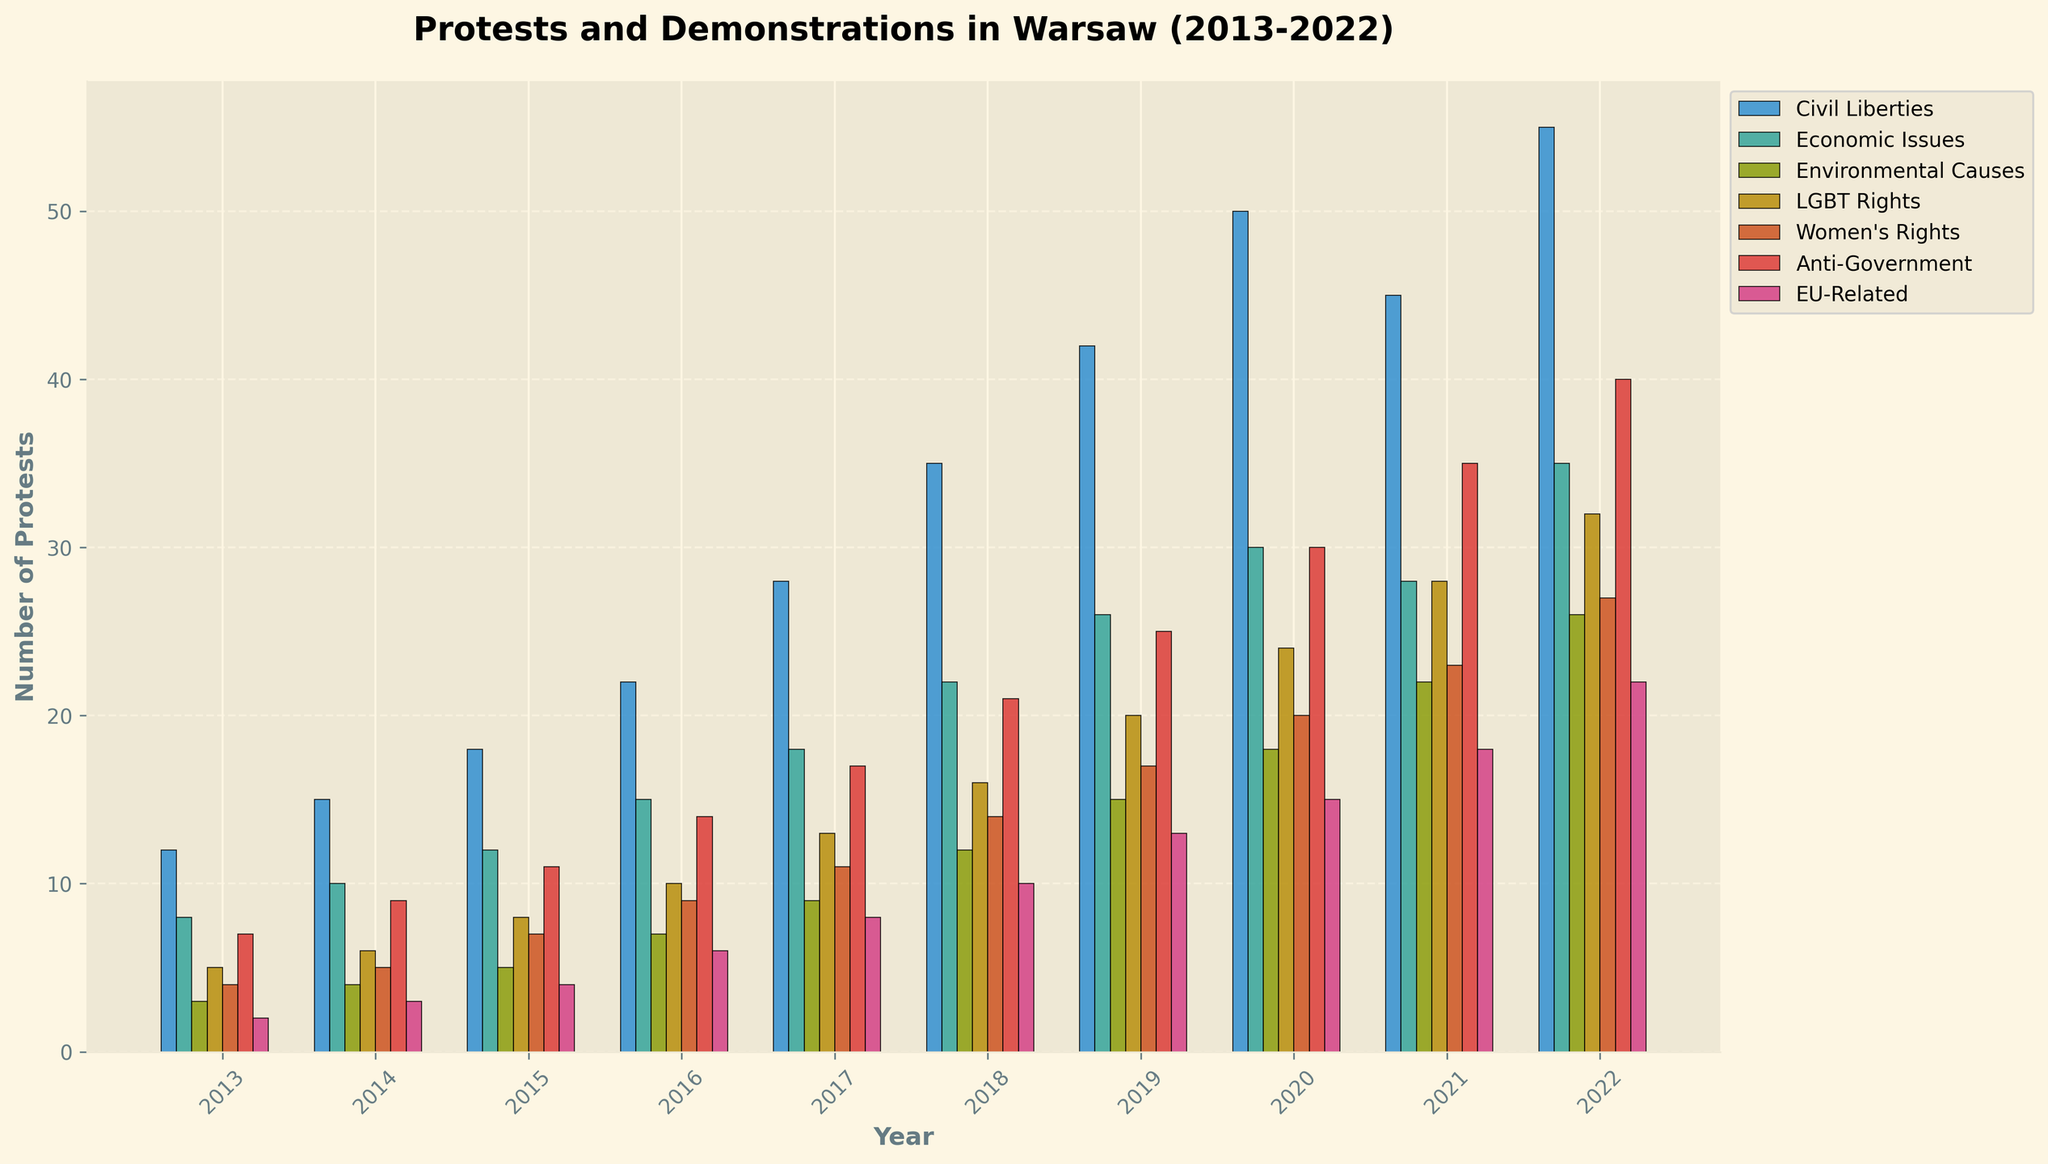What's the total number of protests for Civil Liberties over the decade? Sum the values for Civil Liberties from 2013 to 2022 (12 + 15 + 18 + 22 + 28 + 35 + 42 + 50 + 45 + 55). The operation is 12 + 15 + 18 + 22 + 28 + 35 + 42 + 50 + 45 + 55 = 322.
Answer: 322 In which year did Economic Issues protests peak? Identify the highest bar in the Economic Issues category across all years. The peak is in 2022 with 35 protests.
Answer: 2022 How did the number of Environmental Causes protests change from 2015 to 2021? Calculate the difference between the number of protests in 2015 and 2021 for Environmental Causes. The operation is 22 - 5 = 17.
Answer: Increased by 17 Between 2017 and 2019, which cause had the fastest growth in protests? Compare the growth numbers for all categories between 2017 and 2019. Civil Liberties grew from 28 to 42 (14 increase), and that’s the largest.
Answer: Civil Liberties What's the average number of Anti-Government protests per year? Calculate the average by summing the Anti-Government protests and dividing by 10: (7+9+11+14+17+21+25+30+35+40)/10 = 20.9.
Answer: 20.9 Which category had the lowest number of protests in 2013? Compare the heights of the bars for all categories in 2013. The shortest bar is EU-Related with 2 protests.
Answer: EU-Related What is the net change in LGBT Rights protests from 2013 to 2022? Subtract the number of protests in 2013 from 2022 for LGBT Rights: 32 - 5 = 27.
Answer: Increased by 27 Which year showed the first significant rise for Environmental Causes protests? Look for the first noticeable increase in the height of the Environmental Causes bars. It significantly rises from 2015 to 2016 (5 to 7).
Answer: 2016 By how much did Women's Rights protests increase between 2018 and 2020? Subtract the number of protests in 2018 from 2020 for Women's Rights: 20 - 14 = 6.
Answer: Increased by 6 